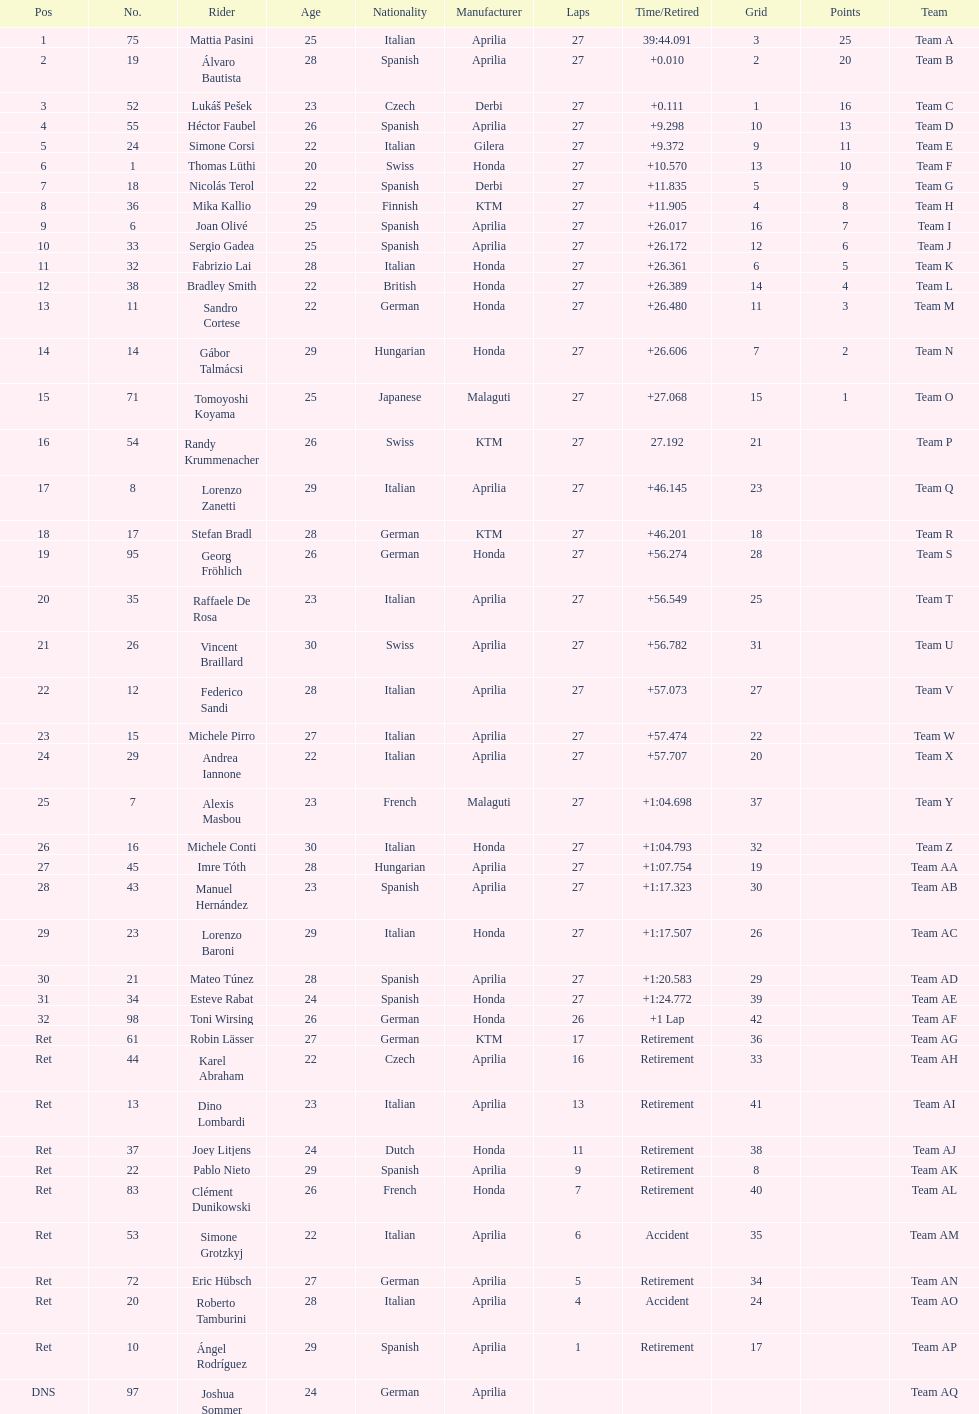Name a racer that had at least 20 points. Mattia Pasini. 